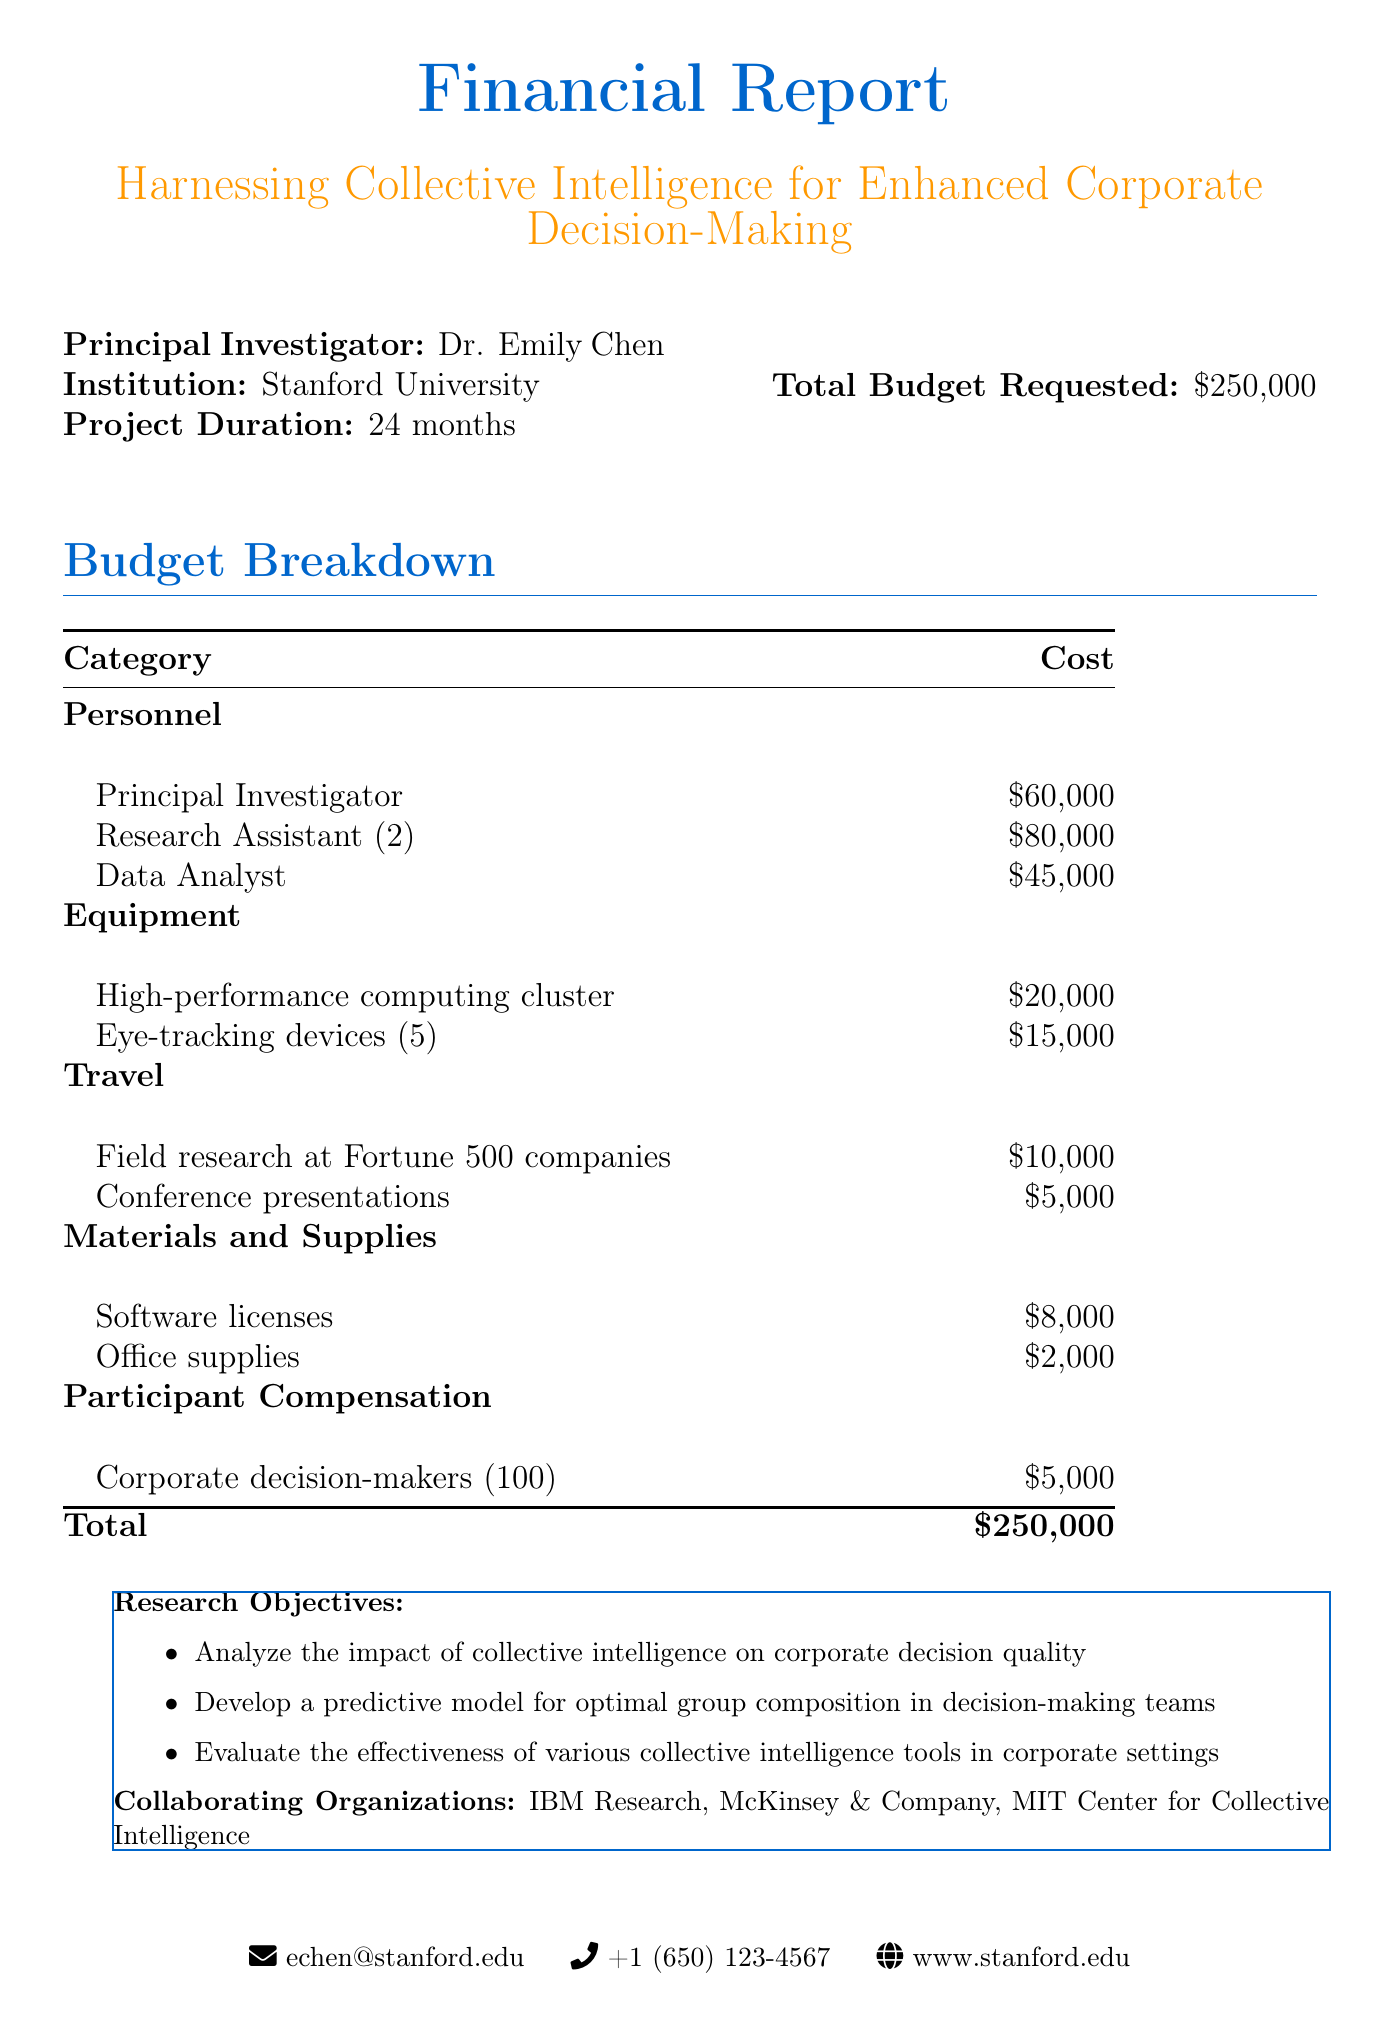what is the project title? The project title is explicitly stated at the beginning of the document.
Answer: Harnessing Collective Intelligence for Enhanced Corporate Decision-Making who is the principal investigator? The principal investigator's name is mentioned under the project details.
Answer: Dr. Emily Chen how much is the total budget requested? The total budget requested is clearly listed in the financial report.
Answer: $250,000 what is the duration of the project? The duration of the project is specified in the document.
Answer: 24 months how many research assistants are included in the budget? The number of research assistants is indicated in the personnel section of the budget breakdown.
Answer: 2 what is one of the research objectives? Research objectives are listed, and one can be selected from that list.
Answer: Analyze the impact of collective intelligence on corporate decision quality what is the cost of the high-performance computing cluster? The cost of specific equipment is detailed in the budget breakdown.
Answer: $20,000 which organization is a collaborating partner? The document names several collaborating organizations, any of which can be an answer.
Answer: IBM Research how much is allocated for participant compensation? The allocated amount for participant compensation is mentioned in the budget details.
Answer: $5,000 what type of approach is used in the methodology? The methodology highlights mention the type of approach used.
Answer: Mixed-methods approach 